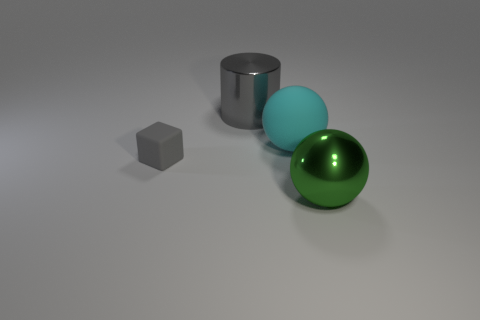How many objects are matte objects to the left of the big gray cylinder or matte objects that are in front of the big cyan object?
Offer a terse response. 1. Is there any other thing of the same color as the large shiny ball?
Ensure brevity in your answer.  No. There is a large thing that is to the right of the sphere that is behind the large thing that is to the right of the large rubber object; what is its color?
Provide a short and direct response. Green. There is a matte object that is left of the large shiny thing behind the rubber block; what is its size?
Keep it short and to the point. Small. What is the thing that is to the right of the small gray matte object and in front of the cyan rubber ball made of?
Provide a succinct answer. Metal. Do the cyan matte object and the metal thing that is behind the green shiny sphere have the same size?
Offer a terse response. Yes. Are any tiny green shiny cylinders visible?
Your answer should be very brief. No. There is a large green thing that is the same shape as the big cyan matte object; what material is it?
Keep it short and to the point. Metal. What is the size of the gray object that is in front of the shiny thing that is left of the large metallic object right of the large gray cylinder?
Your answer should be compact. Small. Are there any large shiny things in front of the rubber ball?
Your answer should be compact. Yes. 